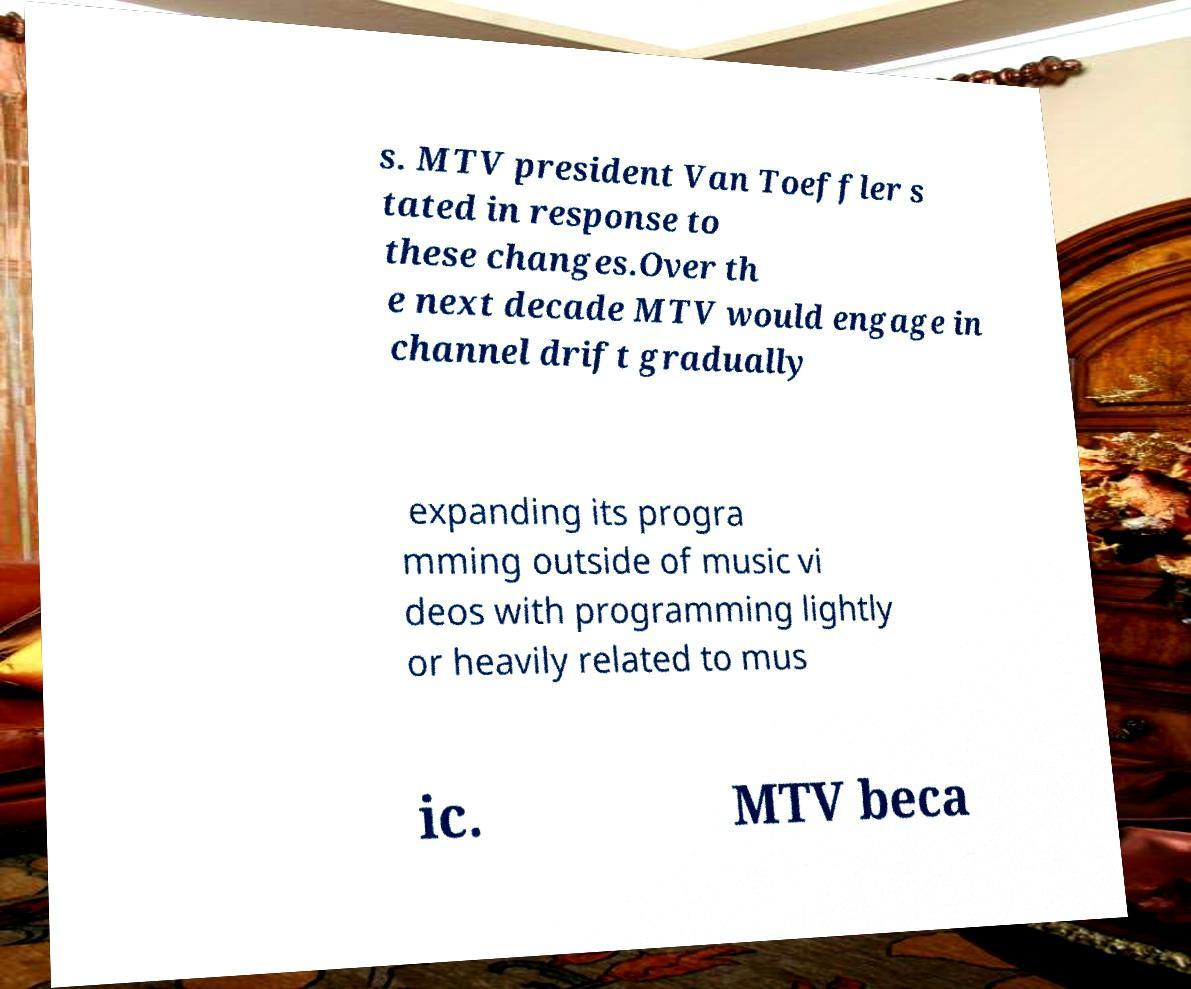Can you accurately transcribe the text from the provided image for me? s. MTV president Van Toeffler s tated in response to these changes.Over th e next decade MTV would engage in channel drift gradually expanding its progra mming outside of music vi deos with programming lightly or heavily related to mus ic. MTV beca 